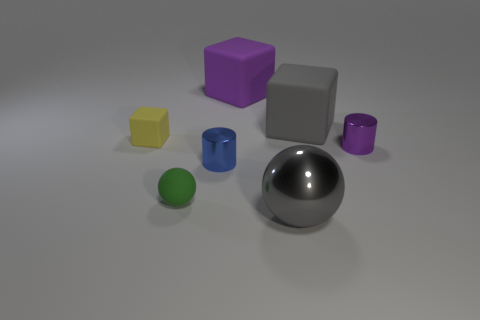There is a gray block that is the same material as the large purple cube; what size is it?
Offer a very short reply. Large. Is the shape of the purple rubber object the same as the yellow rubber object?
Make the answer very short. Yes. What is the color of the block that is the same size as the purple cylinder?
Offer a terse response. Yellow. What is the size of the gray thing that is the same shape as the tiny yellow thing?
Provide a short and direct response. Large. There is a tiny rubber thing behind the purple cylinder; what is its shape?
Give a very brief answer. Cube. Does the big gray shiny thing have the same shape as the small matte thing in front of the small purple metallic object?
Give a very brief answer. Yes. Is the number of purple things in front of the tiny green matte object the same as the number of large matte objects in front of the big purple rubber thing?
Provide a succinct answer. No. Is the color of the shiny cylinder behind the small blue shiny object the same as the large thing behind the gray matte thing?
Give a very brief answer. Yes. Are there more purple metallic things left of the large purple thing than tiny brown cylinders?
Offer a terse response. No. What is the small sphere made of?
Provide a succinct answer. Rubber. 